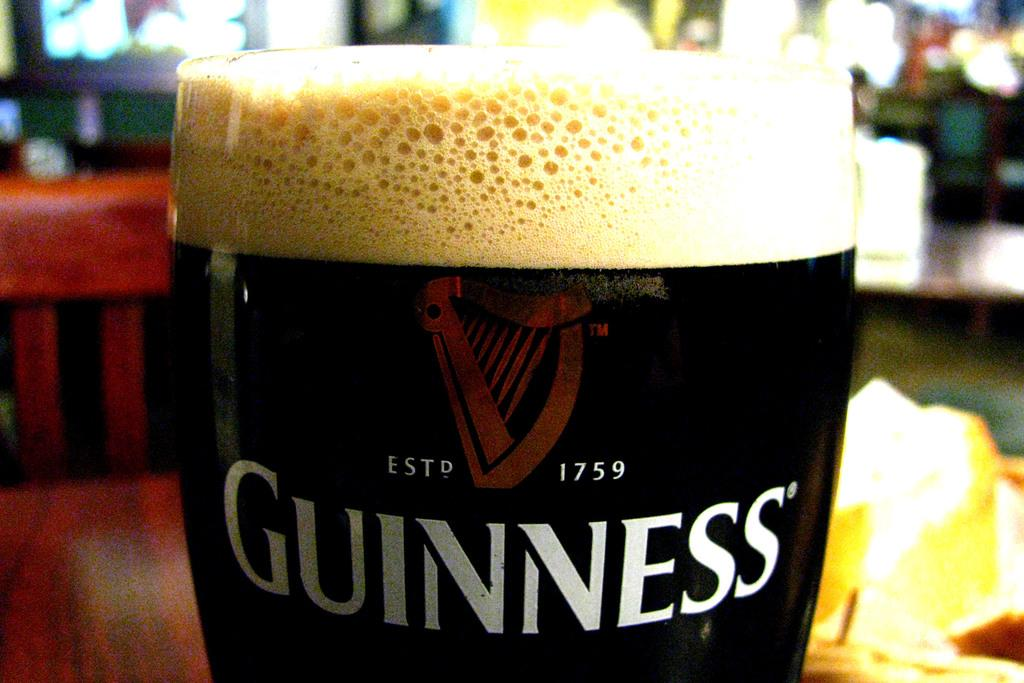<image>
Offer a succinct explanation of the picture presented. A glass of Guinness beer sitting on a restaurant table. 